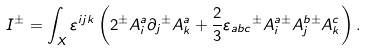<formula> <loc_0><loc_0><loc_500><loc_500>I { ^ { \pm } } = \int _ { X } \varepsilon ^ { i j k } \left ( 2 { ^ { \pm } } A _ { i } ^ { a } \partial _ { j } { ^ { \pm } } A _ { k } ^ { a } + { \frac { 2 } { 3 } } \varepsilon _ { a b c } { ^ { \pm } } A _ { i } ^ { a } { ^ { \pm } } A _ { j } ^ { b } { ^ { \pm } } A _ { k } ^ { c } \right ) .</formula> 